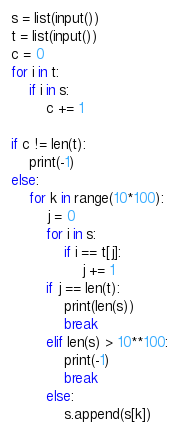<code> <loc_0><loc_0><loc_500><loc_500><_Python_>s = list(input())
t = list(input())
c = 0
for i in t:
    if i in s:
        c += 1
        
if c != len(t):
    print(-1)
else:
    for k in range(10*100):
        j = 0
        for i in s:
            if i == t[j]:
                j += 1
        if j == len(t):
            print(len(s))
            break
        elif len(s) > 10**100:
            print(-1)
            break
        else:
            s.append(s[k])
</code> 